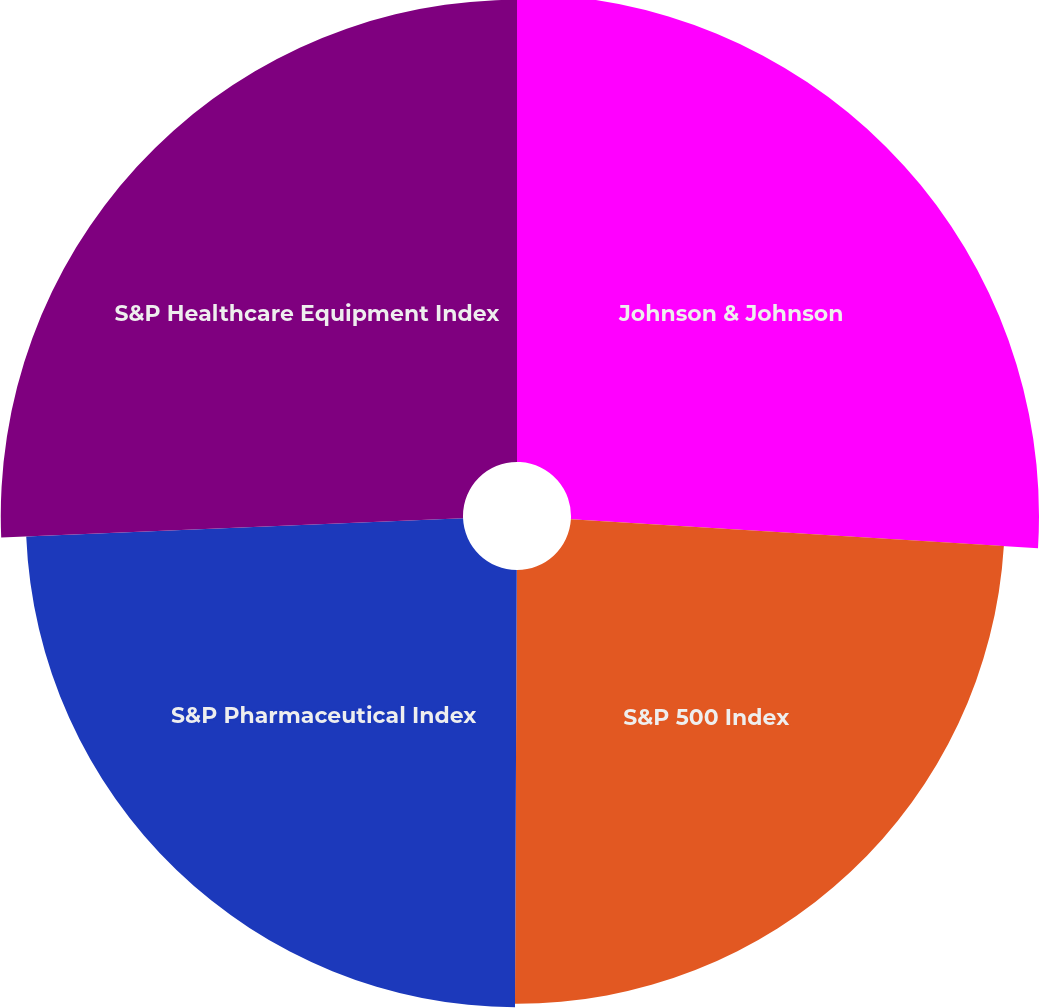<chart> <loc_0><loc_0><loc_500><loc_500><pie_chart><fcel>Johnson & Johnson<fcel>S&P 500 Index<fcel>S&P Pharmaceutical Index<fcel>S&P Healthcare Equipment Index<nl><fcel>25.98%<fcel>24.08%<fcel>24.27%<fcel>25.66%<nl></chart> 